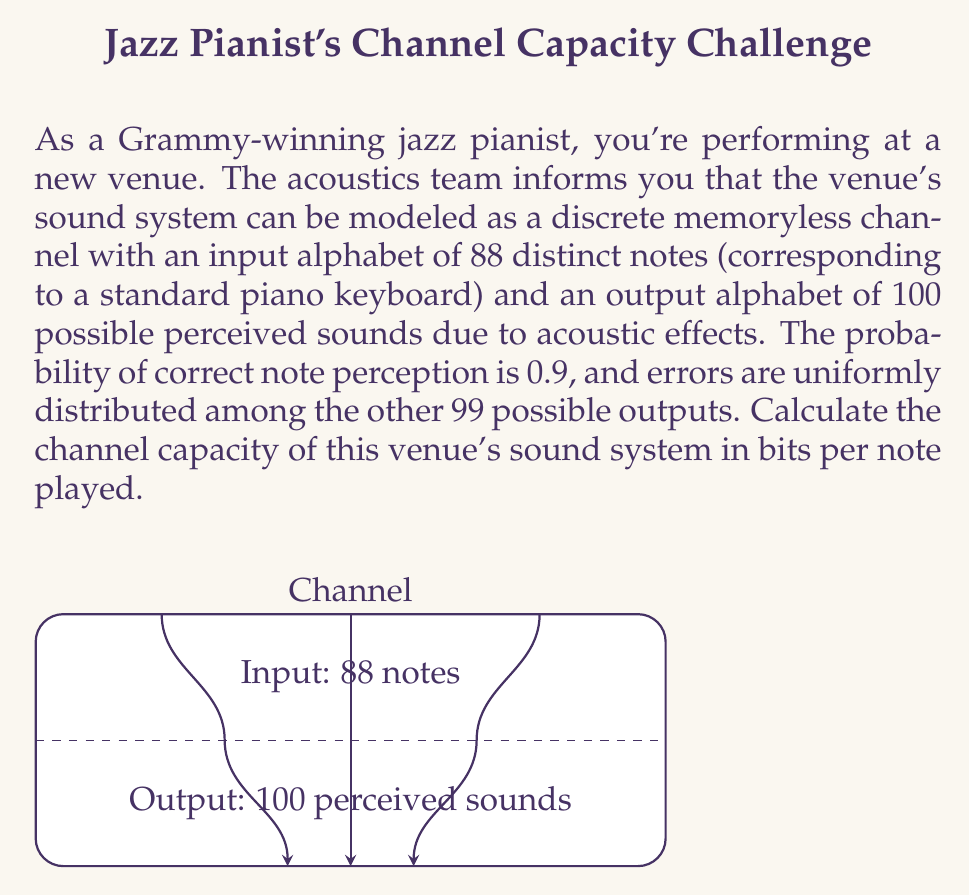Give your solution to this math problem. To calculate the channel capacity, we'll use the mutual information formula and maximize it over all possible input distributions. Given the symmetry of the channel, we can assume that the capacity-achieving input distribution is uniform.

1) First, let's calculate the transition probabilities:
   $p(y|x) = 0.9$ for correct perception
   $p(y|x) = \frac{0.1}{99}$ for each incorrect perception

2) The mutual information for a discrete memoryless channel is given by:
   $I(X;Y) = H(Y) - H(Y|X)$

3) For a uniform input distribution, $H(X) = \log_2(88)$

4) Calculate $H(Y|X)$:
   $H(Y|X) = -0.9 \log_2(0.9) - 99 \cdot \frac{0.1}{99} \log_2(\frac{0.1}{99})$
   $= 0.1368 + 0.6644 = 0.8012$ bits

5) Calculate $H(Y)$:
   $H(Y) = -\sum_{y} p(y) \log_2 p(y)$
   $= -88 \cdot \frac{1}{88}(0.9 \log_2(\frac{0.9}{88}) + 99 \cdot \frac{0.1}{99} \log_2(\frac{0.1}{99 \cdot 88}))$
   $= 6.4594$ bits

6) The channel capacity is:
   $C = \max_{p(x)} I(X;Y) = H(Y) - H(Y|X)$
   $= 6.4594 - 0.8012 = 5.6582$ bits per note played
Answer: $5.6582$ bits per note 